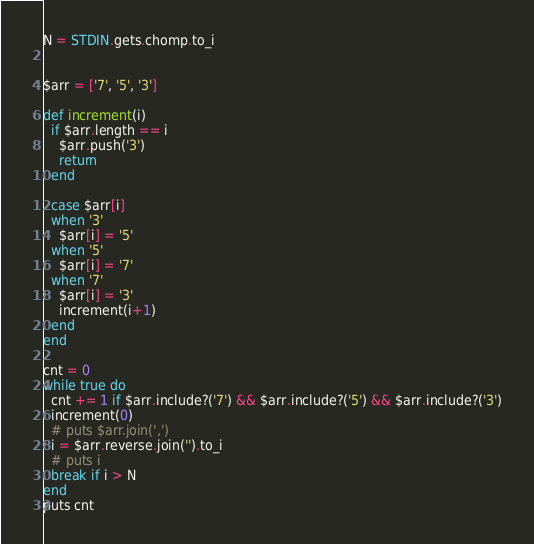<code> <loc_0><loc_0><loc_500><loc_500><_Ruby_>N = STDIN.gets.chomp.to_i


$arr = ['7', '5', '3']

def increment(i)
  if $arr.length == i
    $arr.push('3')
    return
  end

  case $arr[i]
  when '3'
    $arr[i] = '5'
  when '5'
    $arr[i] = '7'
  when '7'
    $arr[i] = '3'
    increment(i+1)
  end
end

cnt = 0
while true do
  cnt += 1 if $arr.include?('7') && $arr.include?('5') && $arr.include?('3')
  increment(0)
  # puts $arr.join(',')
  i = $arr.reverse.join('').to_i
  # puts i
  break if i > N
end
puts cnt
</code> 